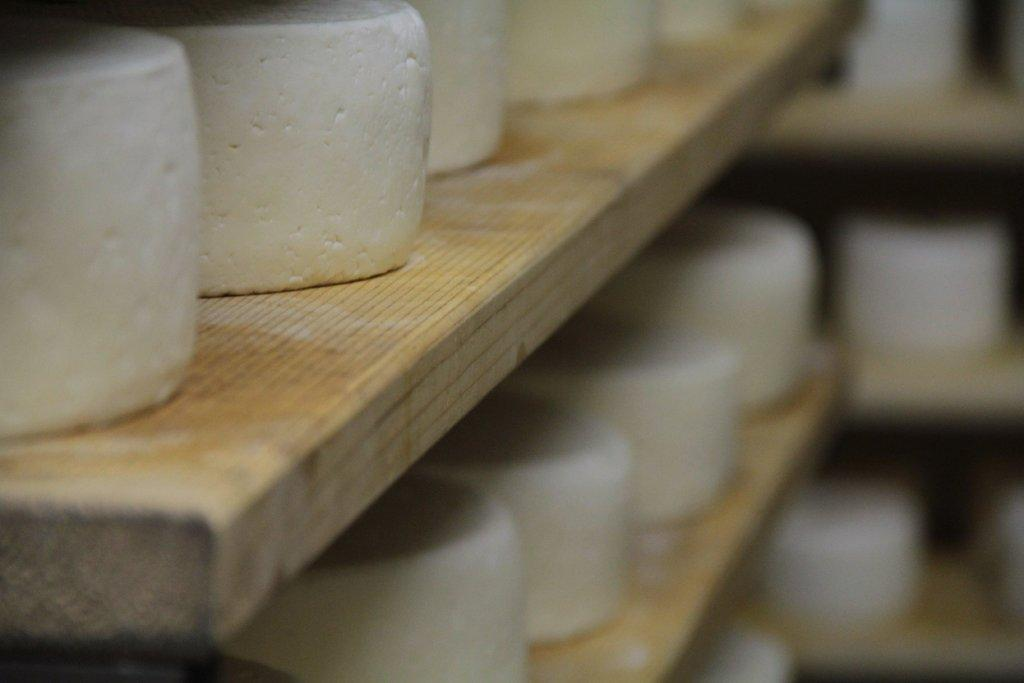What type of food items are present in the image? There are cheeses in the image. Where are the cheeses located? The cheeses are on wooden shelves. What type of vein is visible in the image? There is no vein visible in the image; it features cheeses on wooden shelves. Can you tell me if there are any wounds or diseases present in the image? There are no wounds or diseases present in the image; it features cheeses on wooden shelves. 